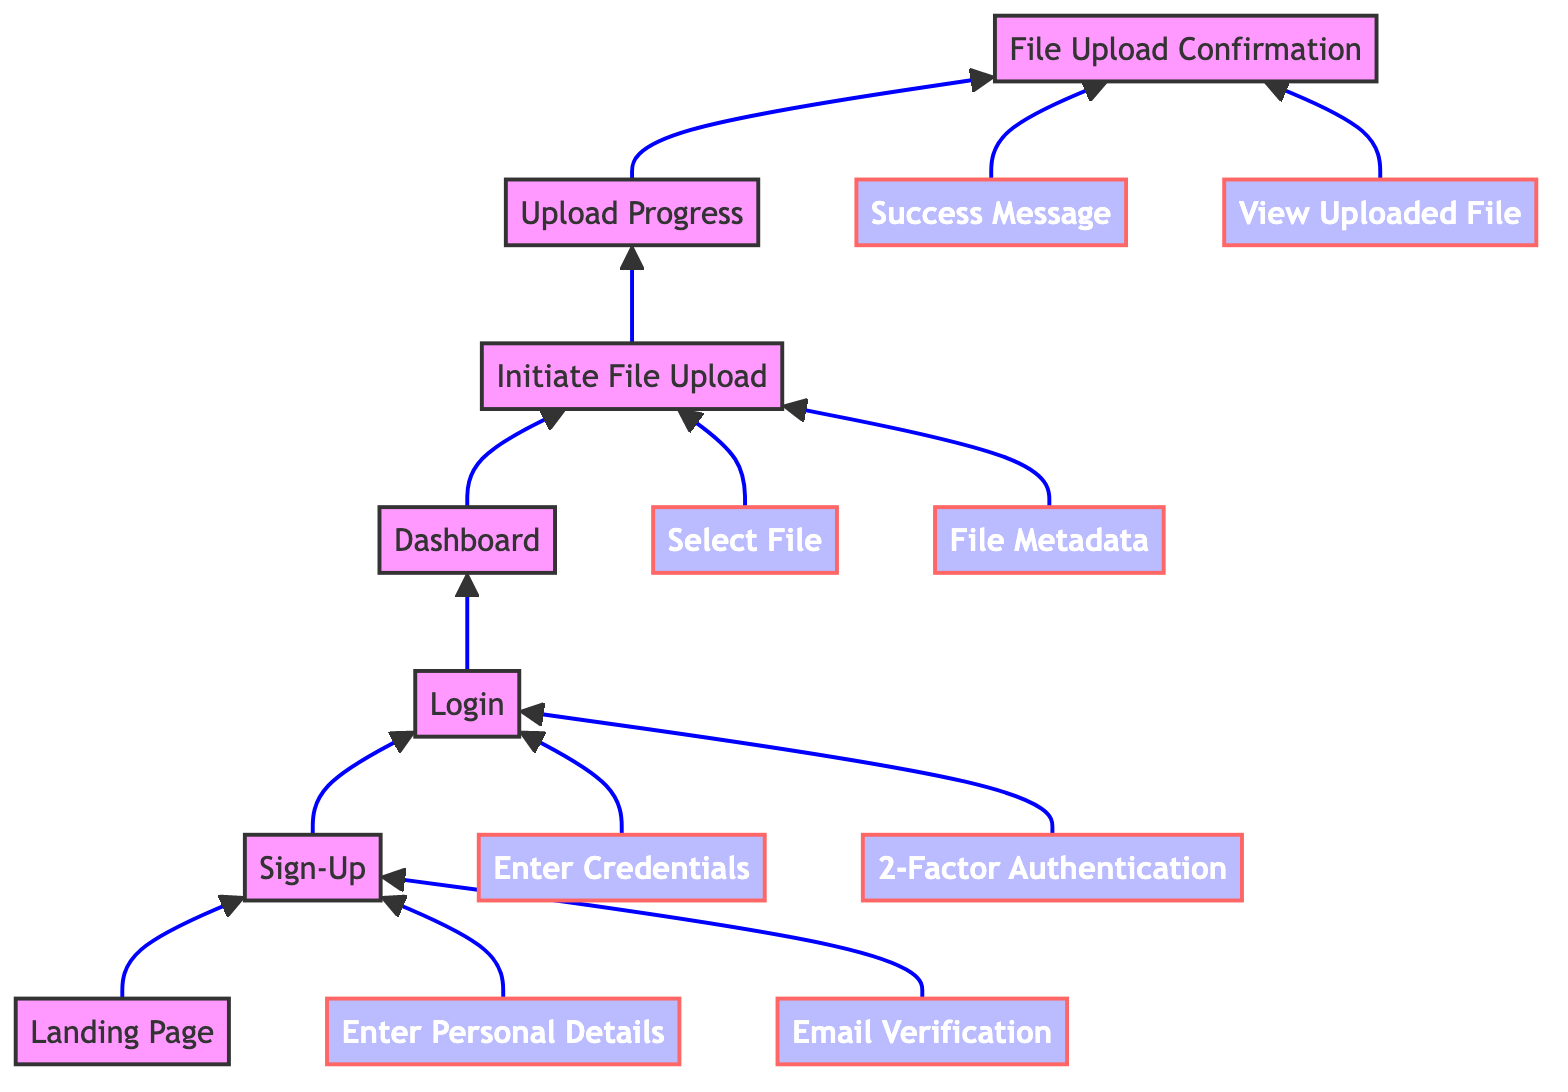What is the first step in the user journey? The first step in the user journey, as per the diagram, is the "Landing Page" where the user initially arrives at the website.
Answer: Landing Page How many major steps are there from Login to File Upload Confirmation? From the "Login" to "File Upload Confirmation," there are three major steps: "Dashboard," "Initiate File Upload," and "Upload Progress."
Answer: Three Which step involves email verification? The "Email Verification" step is a part of the "Sign-Up" process where the user receives a verification email and clicks the link to verify their account.
Answer: Email Verification What does the user do after seeing the "Upload Progress"? After seeing the "Upload Progress," the user moves on to "File Upload Confirmation," indicating that the file upload has likely completed.
Answer: File Upload Confirmation What action must the user take in the "Sign-Up" step? In the "Sign-Up" step, the user must "Enter Personal Details" including name, email, and password to create an account.
Answer: Enter Personal Details What is the last node in this diagram? The last node in the diagram representing the user journey is "File Upload Confirmation," which signals the completion of the upload process.
Answer: File Upload Confirmation Which step allows the user to set file details? "File Metadata" allows the user to enter optional details about the file, such as description and tags, when initiating the file upload.
Answer: File Metadata What step requires two-factor authentication? The "2-Factor Authentication (if enabled)" is a step within the "Login" process that requires additional security verification.
Answer: 2-Factor Authentication How many steps follow the "Initiate File Upload"? Two steps follow "Initiate File Upload," which are "Upload Progress" and then "File Upload Confirmation."
Answer: Two 